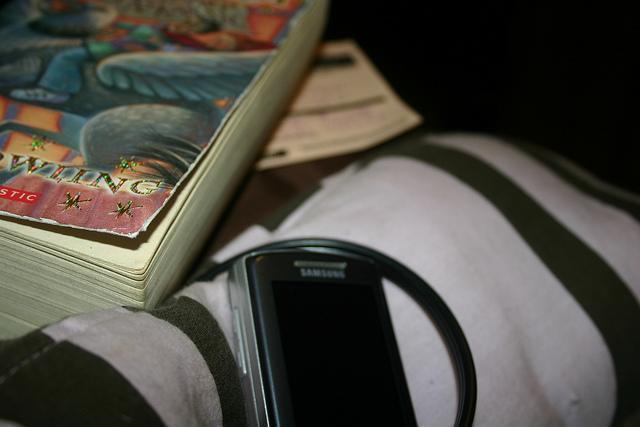How many elephants are there in this photo?
Give a very brief answer. 0. 